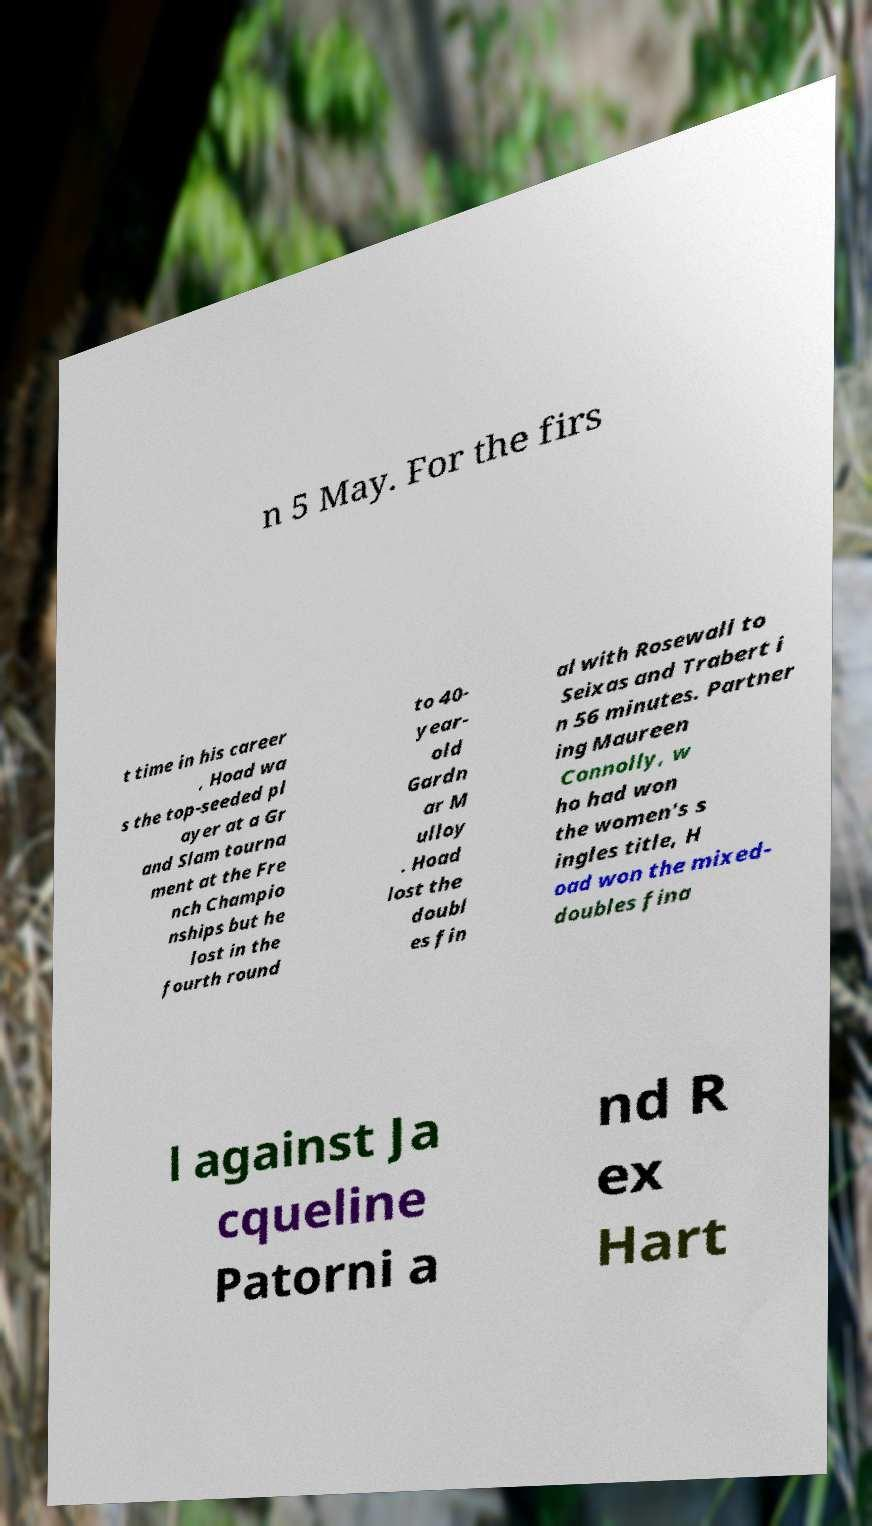I need the written content from this picture converted into text. Can you do that? n 5 May. For the firs t time in his career , Hoad wa s the top-seeded pl ayer at a Gr and Slam tourna ment at the Fre nch Champio nships but he lost in the fourth round to 40- year- old Gardn ar M ulloy . Hoad lost the doubl es fin al with Rosewall to Seixas and Trabert i n 56 minutes. Partner ing Maureen Connolly, w ho had won the women's s ingles title, H oad won the mixed- doubles fina l against Ja cqueline Patorni a nd R ex Hart 